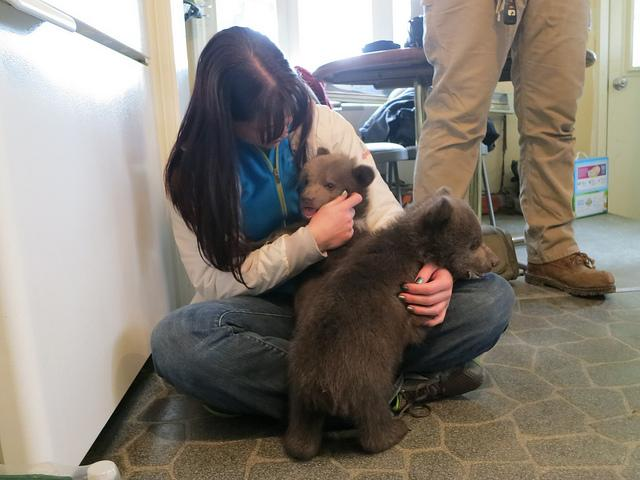The girl is playing with what animals? bears 